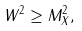Convert formula to latex. <formula><loc_0><loc_0><loc_500><loc_500>W ^ { 2 } \geq M _ { X } ^ { 2 } ,</formula> 